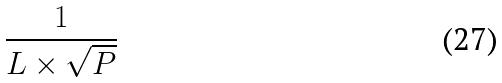Convert formula to latex. <formula><loc_0><loc_0><loc_500><loc_500>\frac { 1 } { L \times \sqrt { P } }</formula> 